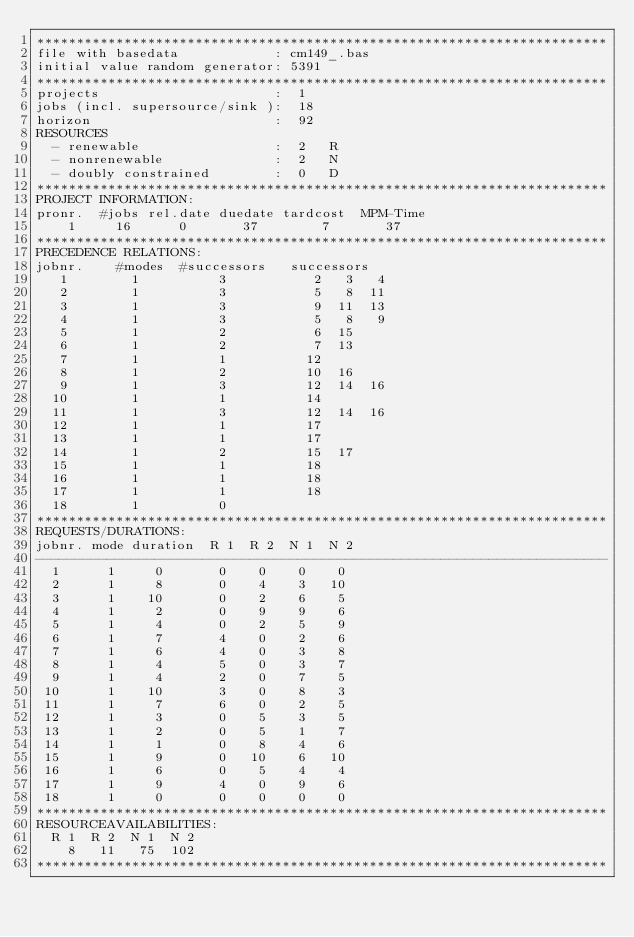<code> <loc_0><loc_0><loc_500><loc_500><_ObjectiveC_>************************************************************************
file with basedata            : cm149_.bas
initial value random generator: 5391
************************************************************************
projects                      :  1
jobs (incl. supersource/sink ):  18
horizon                       :  92
RESOURCES
  - renewable                 :  2   R
  - nonrenewable              :  2   N
  - doubly constrained        :  0   D
************************************************************************
PROJECT INFORMATION:
pronr.  #jobs rel.date duedate tardcost  MPM-Time
    1     16      0       37        7       37
************************************************************************
PRECEDENCE RELATIONS:
jobnr.    #modes  #successors   successors
   1        1          3           2   3   4
   2        1          3           5   8  11
   3        1          3           9  11  13
   4        1          3           5   8   9
   5        1          2           6  15
   6        1          2           7  13
   7        1          1          12
   8        1          2          10  16
   9        1          3          12  14  16
  10        1          1          14
  11        1          3          12  14  16
  12        1          1          17
  13        1          1          17
  14        1          2          15  17
  15        1          1          18
  16        1          1          18
  17        1          1          18
  18        1          0        
************************************************************************
REQUESTS/DURATIONS:
jobnr. mode duration  R 1  R 2  N 1  N 2
------------------------------------------------------------------------
  1      1     0       0    0    0    0
  2      1     8       0    4    3   10
  3      1    10       0    2    6    5
  4      1     2       0    9    9    6
  5      1     4       0    2    5    9
  6      1     7       4    0    2    6
  7      1     6       4    0    3    8
  8      1     4       5    0    3    7
  9      1     4       2    0    7    5
 10      1    10       3    0    8    3
 11      1     7       6    0    2    5
 12      1     3       0    5    3    5
 13      1     2       0    5    1    7
 14      1     1       0    8    4    6
 15      1     9       0   10    6   10
 16      1     6       0    5    4    4
 17      1     9       4    0    9    6
 18      1     0       0    0    0    0
************************************************************************
RESOURCEAVAILABILITIES:
  R 1  R 2  N 1  N 2
    8   11   75  102
************************************************************************
</code> 